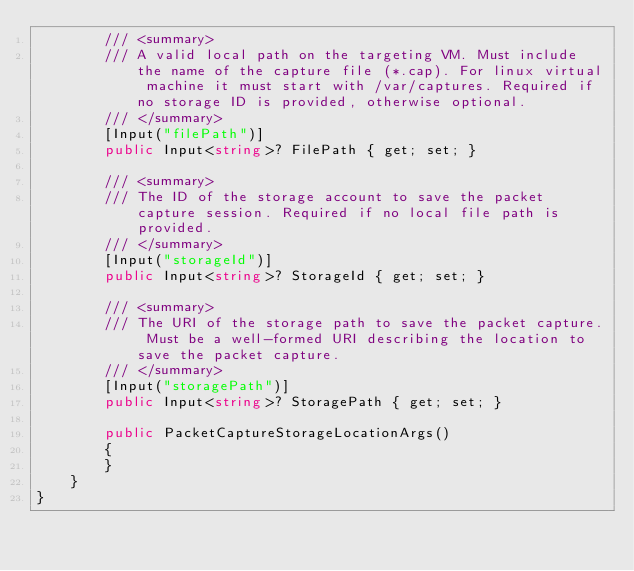Convert code to text. <code><loc_0><loc_0><loc_500><loc_500><_C#_>        /// <summary>
        /// A valid local path on the targeting VM. Must include the name of the capture file (*.cap). For linux virtual machine it must start with /var/captures. Required if no storage ID is provided, otherwise optional.
        /// </summary>
        [Input("filePath")]
        public Input<string>? FilePath { get; set; }

        /// <summary>
        /// The ID of the storage account to save the packet capture session. Required if no local file path is provided.
        /// </summary>
        [Input("storageId")]
        public Input<string>? StorageId { get; set; }

        /// <summary>
        /// The URI of the storage path to save the packet capture. Must be a well-formed URI describing the location to save the packet capture.
        /// </summary>
        [Input("storagePath")]
        public Input<string>? StoragePath { get; set; }

        public PacketCaptureStorageLocationArgs()
        {
        }
    }
}
</code> 